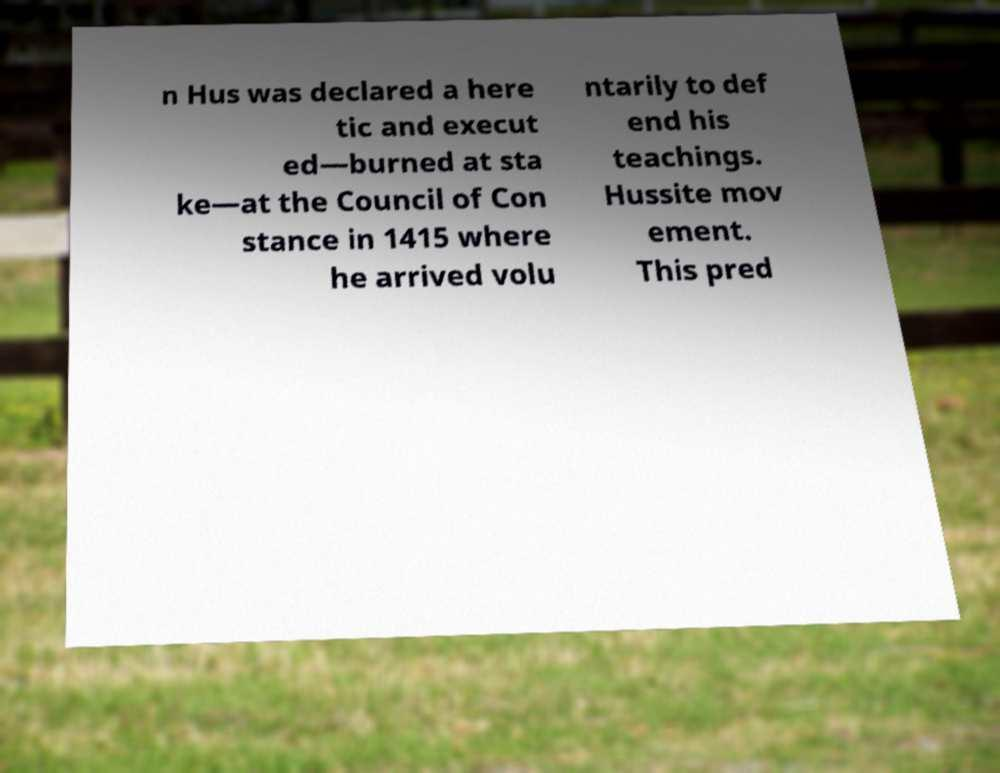There's text embedded in this image that I need extracted. Can you transcribe it verbatim? n Hus was declared a here tic and execut ed—burned at sta ke—at the Council of Con stance in 1415 where he arrived volu ntarily to def end his teachings. Hussite mov ement. This pred 